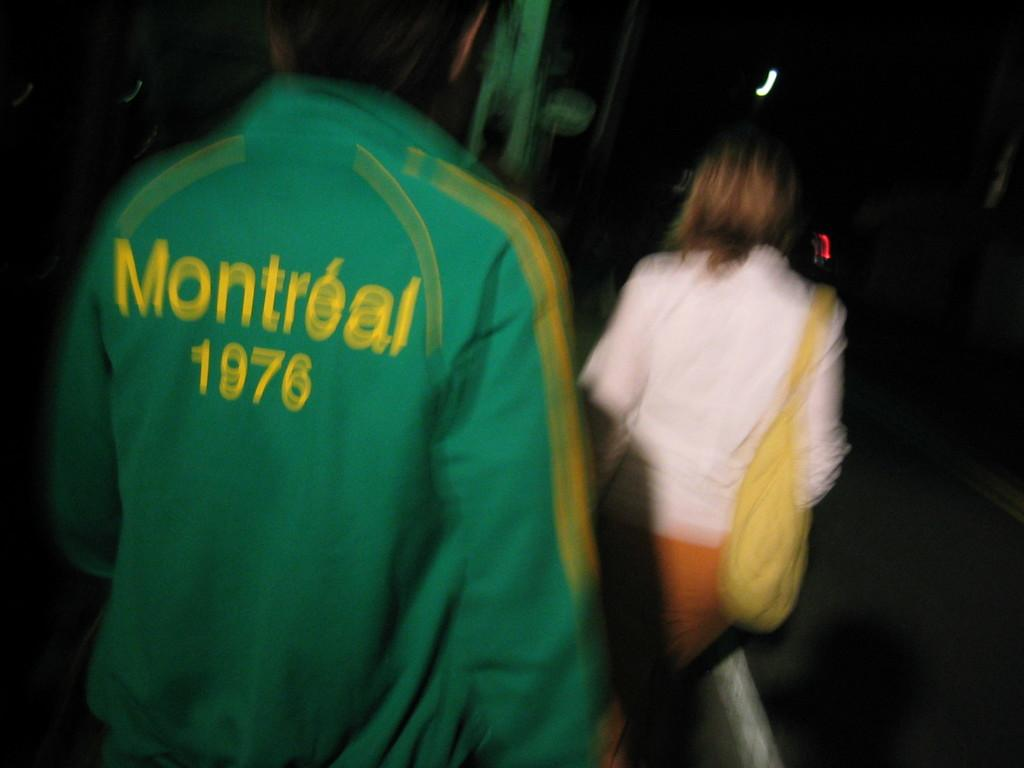<image>
Describe the image concisely. A man wearing a green Montreal 1976 jacket walks down a dark street 